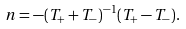<formula> <loc_0><loc_0><loc_500><loc_500>n = - ( T _ { + } + T _ { - } ) ^ { - 1 } ( T _ { + } - T _ { - } ) .</formula> 